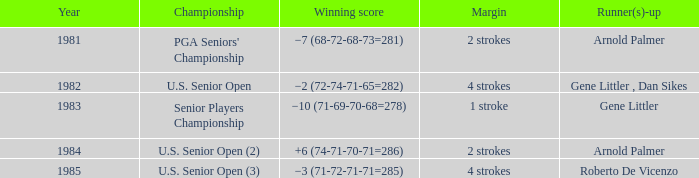What margin was in after 1981, and was Roberto De Vicenzo runner-up? 4 strokes. 